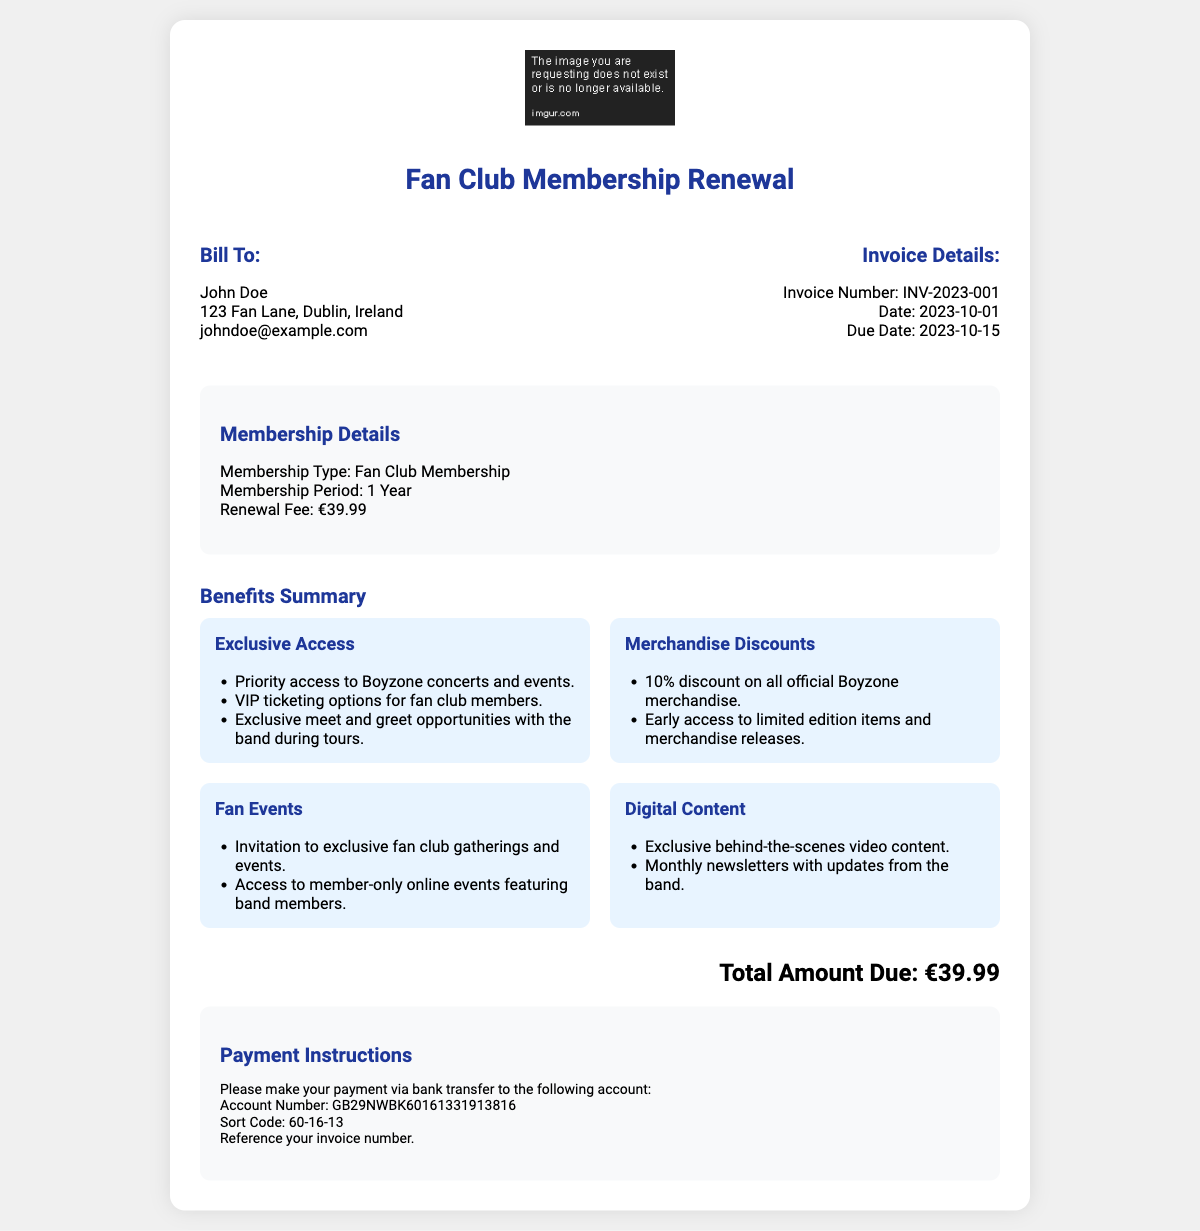What is the membership period? The membership period is specified in the document as 1 Year.
Answer: 1 Year What is the renewal fee? The renewal fee is mentioned in the document as €39.99.
Answer: €39.99 What is the due date for payment? The due date for payment is listed in the document as 2023-10-15.
Answer: 2023-10-15 Who is the invoice billed to? The document specifies that the invoice is billed to John Doe.
Answer: John Doe What type of membership is this invoice for? The document states that this invoice is for Fan Club Membership.
Answer: Fan Club Membership How many categories of benefits are summarized? The document lists four categories of benefits: Exclusive Access, Merchandise Discounts, Fan Events, and Digital Content.
Answer: 4 What is one benefit of exclusive access? The document lists several benefits under exclusive access, one being priority access to Boyzone concerts and events.
Answer: Priority access to Boyzone concerts and events What payment method is specified in the document? The document specifies payment via bank transfer.
Answer: Bank transfer What is the total amount due? The total amount due is clearly stated in the document as €39.99.
Answer: €39.99 